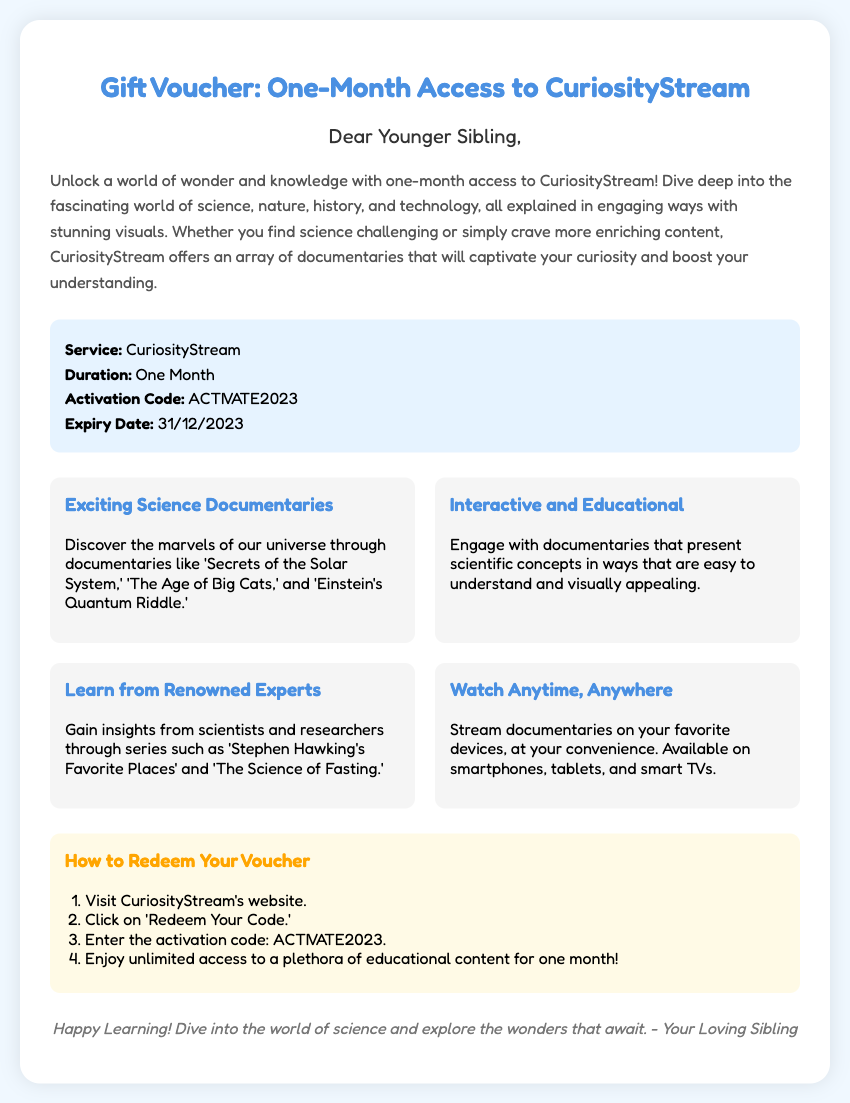What is the name of the service? The document mentions that the service is CuriosityStream.
Answer: CuriosityStream What is the duration of the gift voucher? The document states that the duration is one month.
Answer: One Month What is the activation code? The document provides the activation code as ACTIVATE2023.
Answer: ACTIVATE2023 What is the expiry date of the voucher? The expiry date listed in the document is 31/12/2023.
Answer: 31/12/2023 What type of content does CuriosityStream offer? The document highlights that CuriosityStream offers exciting science documentaries.
Answer: Science documentaries How can you redeem the voucher? The document outlines a step-by-step process for redeeming, starting with visiting CuriosityStream's website.
Answer: Visit CuriosityStream's website Which documentary is mentioned as an example? The document refers to 'Secrets of the Solar System' as an example of a documentary.
Answer: Secrets of the Solar System Who is the target recipient of this voucher? The document indicates that the recipient is referred to as "Younger Sibling."
Answer: Younger Sibling What type of devices can you stream on? The document states that you can stream on smartphones, tablets, and smart TVs.
Answer: Smartphones, tablets, and smart TVs 